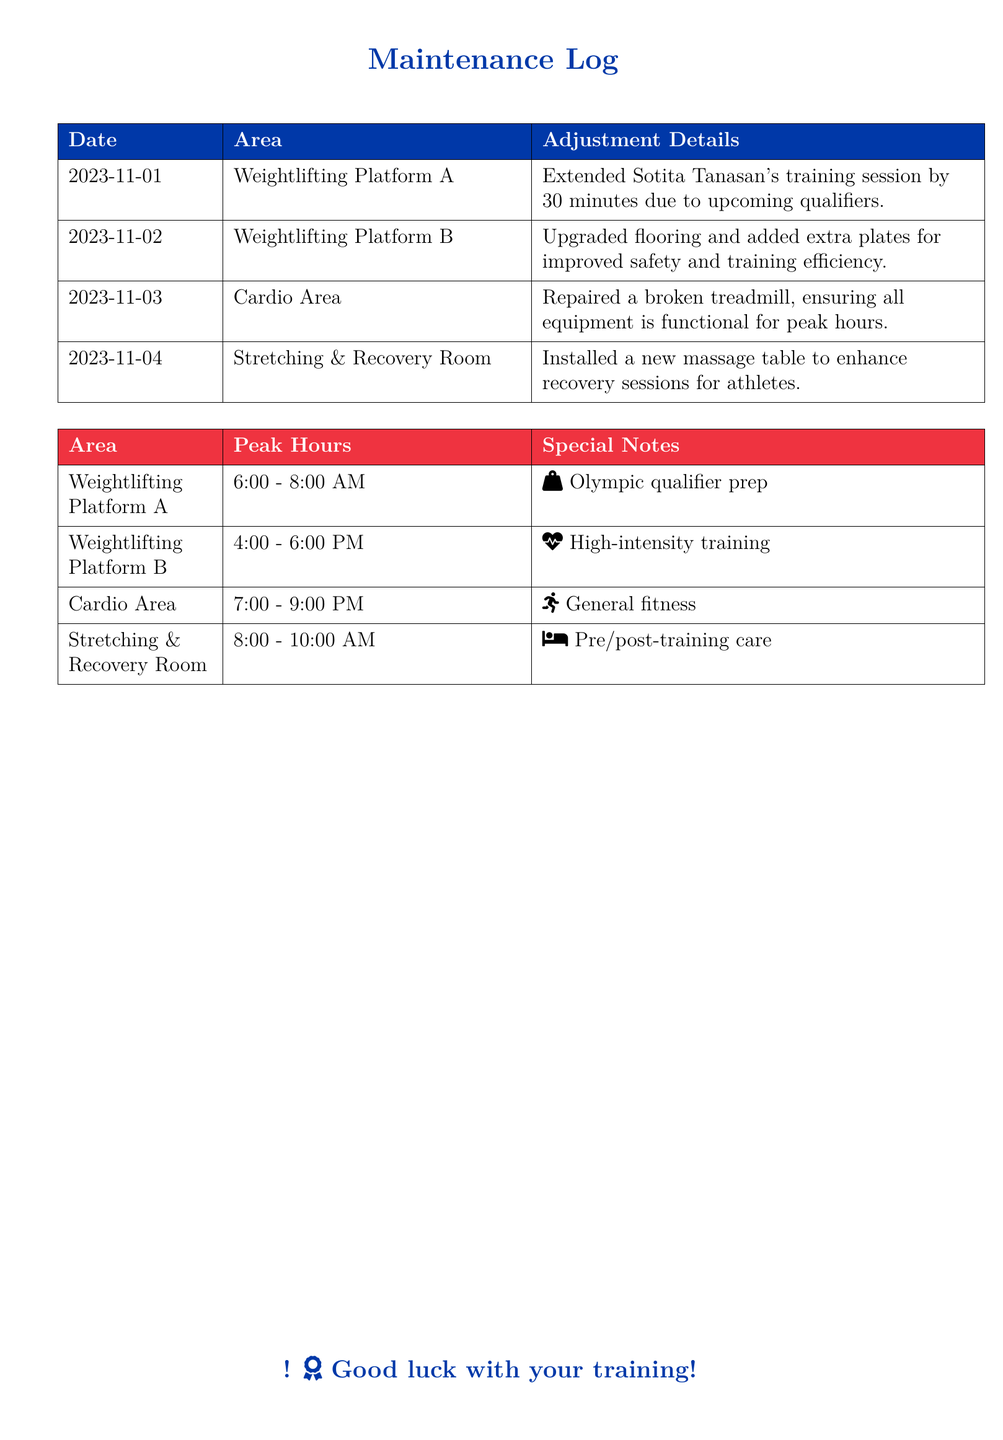What date was Sotita Tanasan's training session adjusted? The document states that her session was extended on November 1, 2023.
Answer: November 1, 2023 What was installed in the Stretching & Recovery Room? A new massage table was installed to enhance recovery sessions for athletes.
Answer: Massage table What time does the peak usage of Weightlifting Platform B occur? The peak hours for Weightlifting Platform B are noted as 4:00 - 6:00 PM.
Answer: 4:00 - 6:00 PM How long was Sotita Tanasan's training session extended? The adjustment detail indicates it was extended by 30 minutes.
Answer: 30 minutes Which area had a treadmill repaired? The Cardio Area had a broken treadmill repaired ensuring functionality.
Answer: Cardio Area What feature was upgraded in Weightlifting Platform B? The document specifies an upgrade to the flooring for improved safety and efficiency.
Answer: Flooring What is the peak hour range for the Stretching & Recovery Room? The document indicates the peak hours are from 8:00 - 10:00 AM.
Answer: 8:00 - 10:00 AM Which area is dedicated to Olympic qualifier preparation? The document states that Weightlifting Platform A is designated for Olympic qualifier prep.
Answer: Weightlifting Platform A 